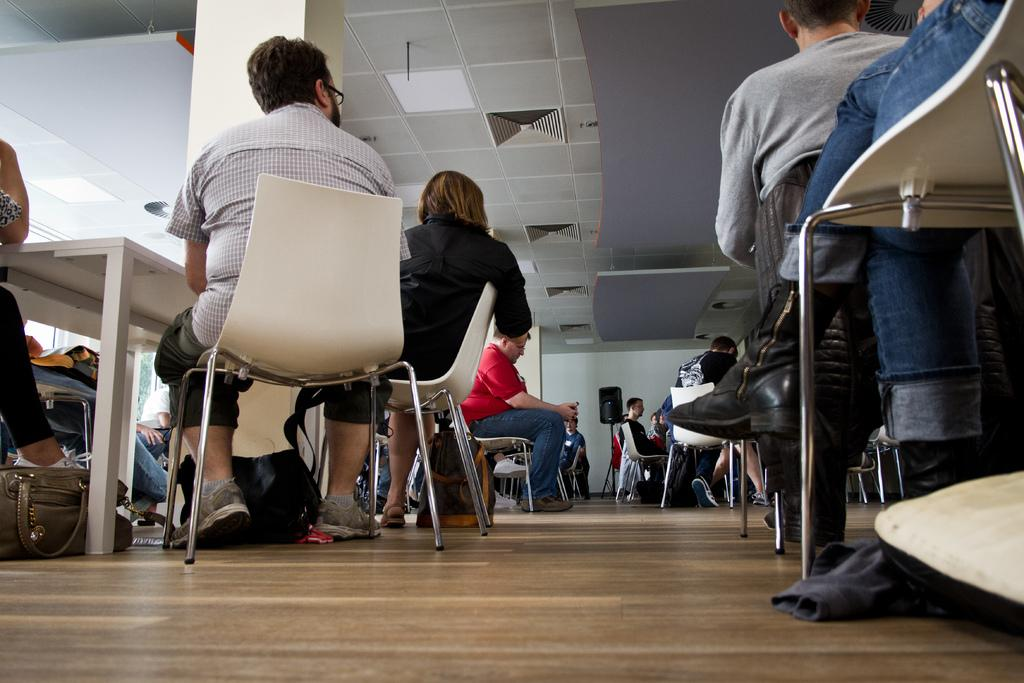What are the people in the image doing? The people in the image are sitting on chairs. Where are the chairs located in relation to the table? The chairs are near a table. What object can be seen near the people? There is a handbag in the image. What type of electronic device is present in the image? There is a speaker box in the image. What part of the room can be seen in the image? The ceiling is visible in the image. What type of shoe is being worn by the person sitting on the chair? There is no information about shoes in the image, as the focus is on the people sitting on chairs, the table, the handbag, the speaker box, and the ceiling. 